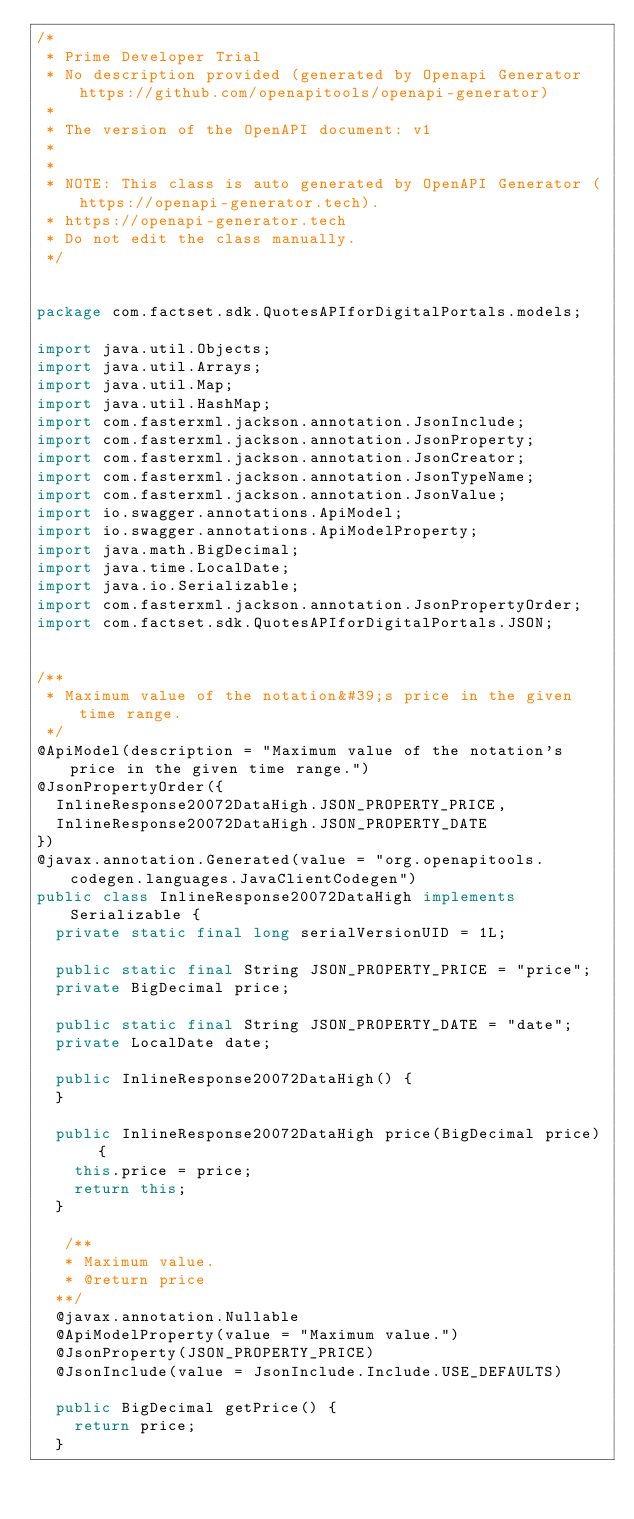Convert code to text. <code><loc_0><loc_0><loc_500><loc_500><_Java_>/*
 * Prime Developer Trial
 * No description provided (generated by Openapi Generator https://github.com/openapitools/openapi-generator)
 *
 * The version of the OpenAPI document: v1
 * 
 *
 * NOTE: This class is auto generated by OpenAPI Generator (https://openapi-generator.tech).
 * https://openapi-generator.tech
 * Do not edit the class manually.
 */


package com.factset.sdk.QuotesAPIforDigitalPortals.models;

import java.util.Objects;
import java.util.Arrays;
import java.util.Map;
import java.util.HashMap;
import com.fasterxml.jackson.annotation.JsonInclude;
import com.fasterxml.jackson.annotation.JsonProperty;
import com.fasterxml.jackson.annotation.JsonCreator;
import com.fasterxml.jackson.annotation.JsonTypeName;
import com.fasterxml.jackson.annotation.JsonValue;
import io.swagger.annotations.ApiModel;
import io.swagger.annotations.ApiModelProperty;
import java.math.BigDecimal;
import java.time.LocalDate;
import java.io.Serializable;
import com.fasterxml.jackson.annotation.JsonPropertyOrder;
import com.factset.sdk.QuotesAPIforDigitalPortals.JSON;


/**
 * Maximum value of the notation&#39;s price in the given time range.
 */
@ApiModel(description = "Maximum value of the notation's price in the given time range.")
@JsonPropertyOrder({
  InlineResponse20072DataHigh.JSON_PROPERTY_PRICE,
  InlineResponse20072DataHigh.JSON_PROPERTY_DATE
})
@javax.annotation.Generated(value = "org.openapitools.codegen.languages.JavaClientCodegen")
public class InlineResponse20072DataHigh implements Serializable {
  private static final long serialVersionUID = 1L;

  public static final String JSON_PROPERTY_PRICE = "price";
  private BigDecimal price;

  public static final String JSON_PROPERTY_DATE = "date";
  private LocalDate date;

  public InlineResponse20072DataHigh() { 
  }

  public InlineResponse20072DataHigh price(BigDecimal price) {
    this.price = price;
    return this;
  }

   /**
   * Maximum value.
   * @return price
  **/
  @javax.annotation.Nullable
  @ApiModelProperty(value = "Maximum value.")
  @JsonProperty(JSON_PROPERTY_PRICE)
  @JsonInclude(value = JsonInclude.Include.USE_DEFAULTS)

  public BigDecimal getPrice() {
    return price;
  }

</code> 